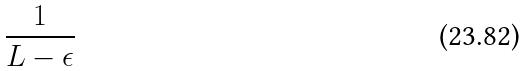Convert formula to latex. <formula><loc_0><loc_0><loc_500><loc_500>\frac { 1 } { L - \epsilon }</formula> 